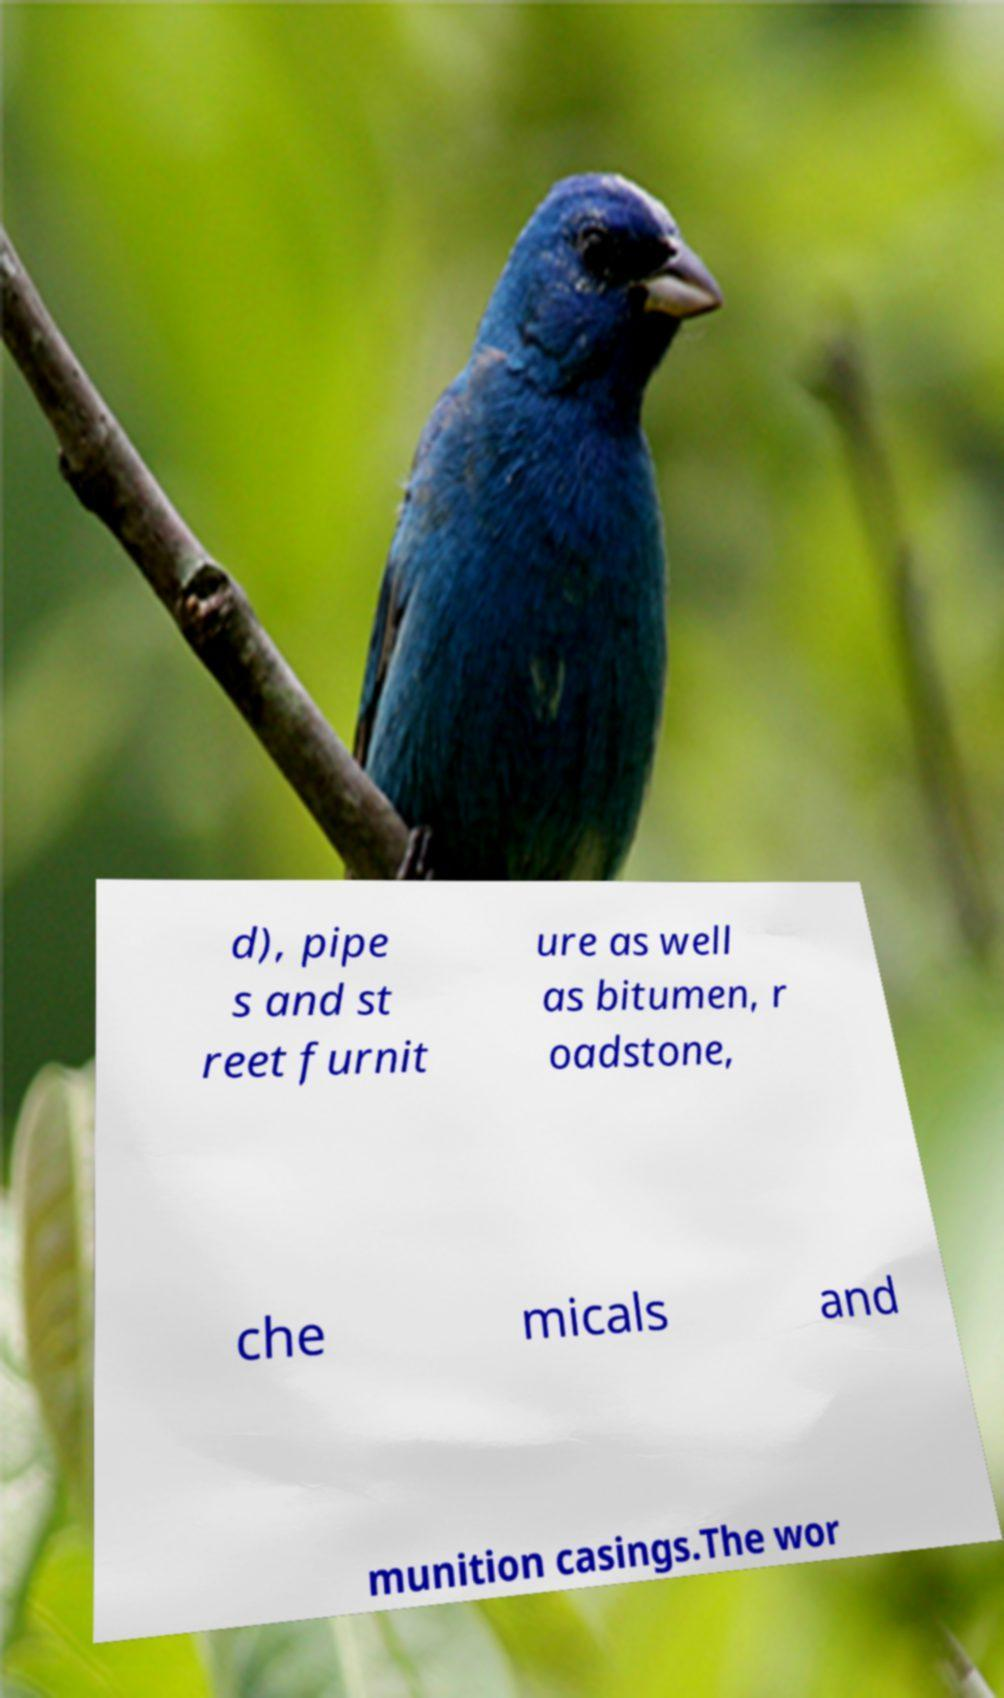Could you assist in decoding the text presented in this image and type it out clearly? d), pipe s and st reet furnit ure as well as bitumen, r oadstone, che micals and munition casings.The wor 